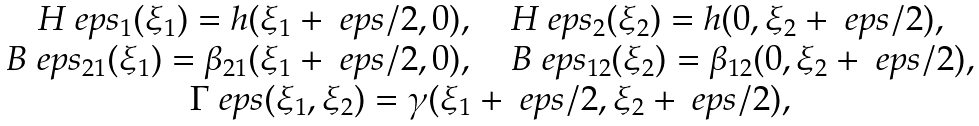<formula> <loc_0><loc_0><loc_500><loc_500>\begin{array} { c } H ^ { \ } e p s _ { 1 } ( \xi _ { 1 } ) = h ( \xi _ { 1 } + \ e p s / 2 , 0 ) , \quad H ^ { \ } e p s _ { 2 } ( \xi _ { 2 } ) = h ( 0 , \xi _ { 2 } + \ e p s / 2 ) , \\ B ^ { \ } e p s _ { 2 1 } ( \xi _ { 1 } ) = \beta _ { 2 1 } ( \xi _ { 1 } + \ e p s / 2 , 0 ) , \quad B ^ { \ } e p s _ { 1 2 } ( \xi _ { 2 } ) = \beta _ { 1 2 } ( 0 , \xi _ { 2 } + \ e p s / 2 ) , \\ \Gamma ^ { \ } e p s ( \xi _ { 1 } , \xi _ { 2 } ) = \gamma ( \xi _ { 1 } + \ e p s / 2 , \xi _ { 2 } + \ e p s / 2 ) , \end{array}</formula> 